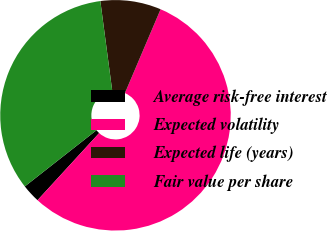<chart> <loc_0><loc_0><loc_500><loc_500><pie_chart><fcel>Average risk-free interest<fcel>Expected volatility<fcel>Expected life (years)<fcel>Fair value per share<nl><fcel>2.59%<fcel>55.42%<fcel>8.5%<fcel>33.49%<nl></chart> 